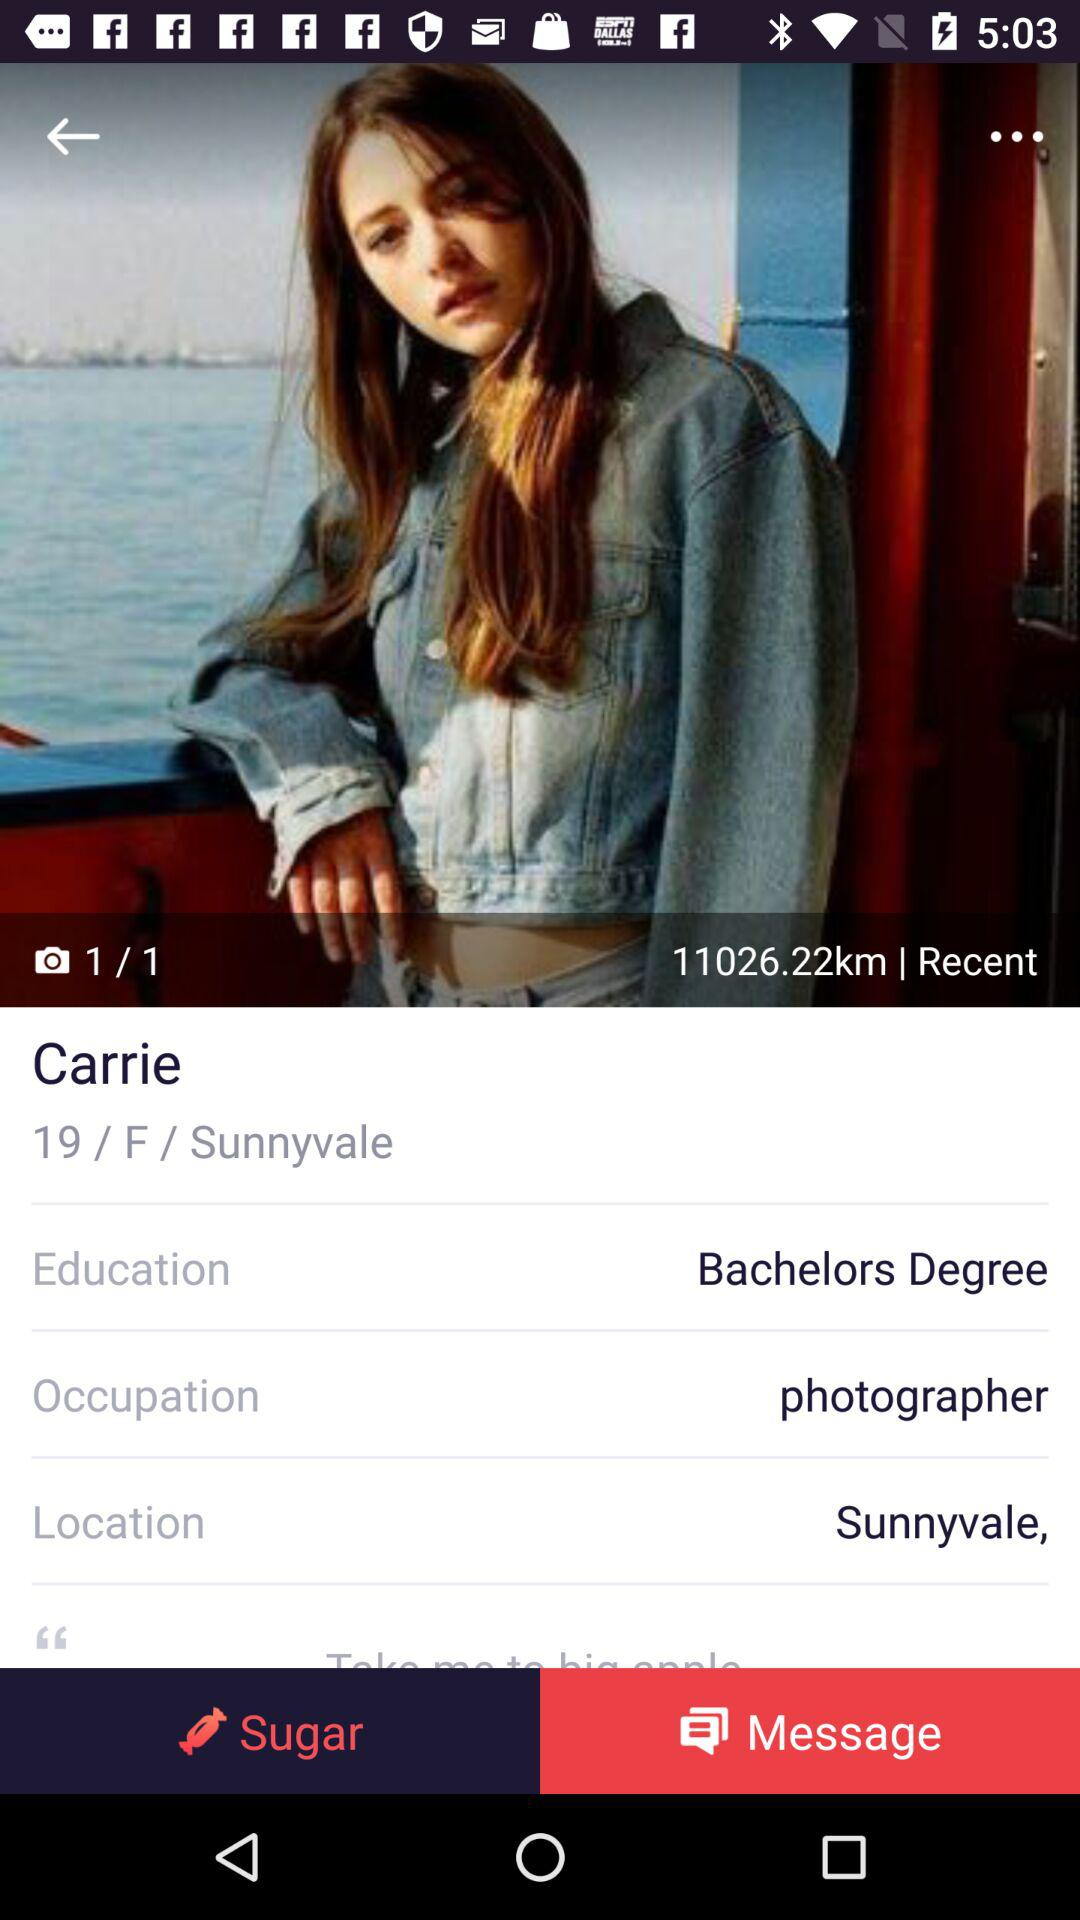What is the occupation of the girl? The occupation of the girl is photographer. 